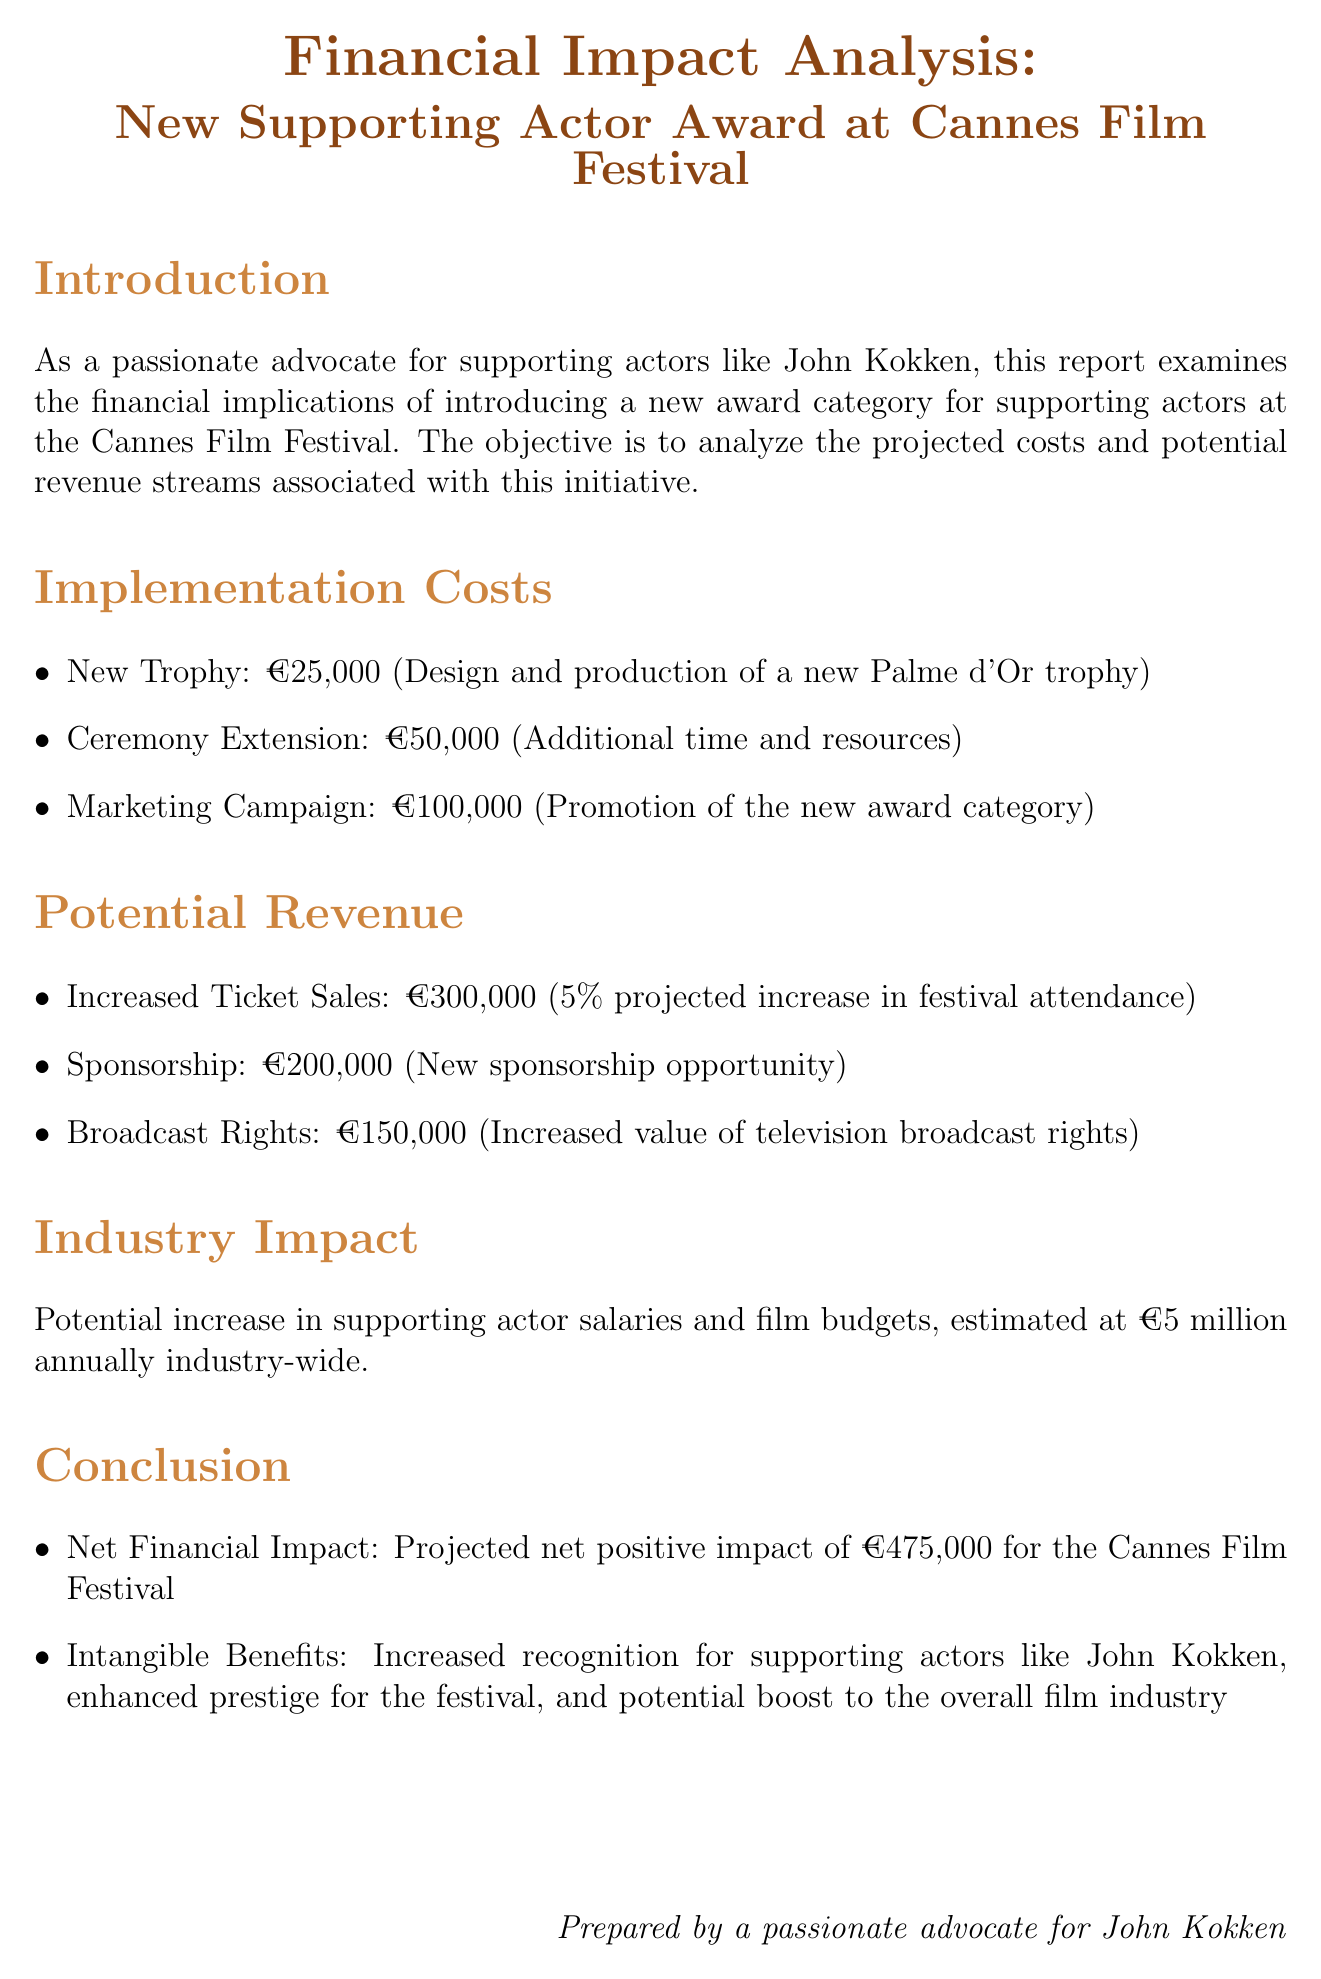What is the estimated cost for the new trophy? The document states that the estimated cost for the new trophy is €25,000.
Answer: €25,000 What is the projected increase in festival attendance? The report indicates a 5% projected increase in festival attendance due to heightened interest.
Answer: 5% What is the total estimated implementation cost? The total estimated implementation cost is the sum of the new trophy, ceremony extension, and marketing campaign costs, amounting to €175,000.
Answer: €175,000 What is the projected net financial impact of the new award category? The document mentions a projected net positive impact of €475,000 for the Cannes Film Festival.
Answer: €475,000 How much revenue is expected from increased ticket sales? The report estimates revenue from increased ticket sales at €300,000.
Answer: €300,000 What is the estimated industry-wide effect of this initiative? The document describes the estimated industry-wide effect as €5 million annually.
Answer: €5 million What is one of the intangible benefits mentioned? The report lists several intangible benefits, one being increased recognition for supporting actors like John Kokken.
Answer: Increased recognition for supporting actors How much revenue is projected from sponsorships? The expected revenue from sponsorships is stated as €200,000.
Answer: €200,000 What is the estimated revenue from broadcast rights? The document indicates an estimated revenue from broadcast rights of €150,000.
Answer: €150,000 